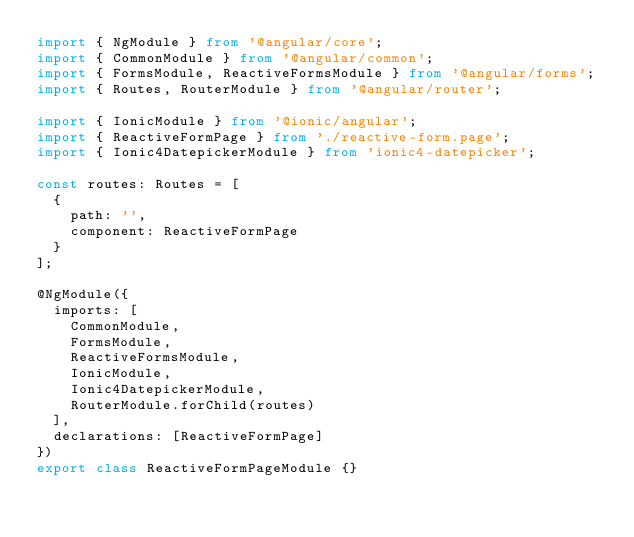<code> <loc_0><loc_0><loc_500><loc_500><_TypeScript_>import { NgModule } from '@angular/core';
import { CommonModule } from '@angular/common';
import { FormsModule, ReactiveFormsModule } from '@angular/forms';
import { Routes, RouterModule } from '@angular/router';

import { IonicModule } from '@ionic/angular';
import { ReactiveFormPage } from './reactive-form.page';
import { Ionic4DatepickerModule } from 'ionic4-datepicker';

const routes: Routes = [
  {
    path: '',
    component: ReactiveFormPage
  }
];

@NgModule({
  imports: [
    CommonModule,
    FormsModule,
    ReactiveFormsModule,
    IonicModule,
    Ionic4DatepickerModule,
    RouterModule.forChild(routes)
  ],
  declarations: [ReactiveFormPage]
})
export class ReactiveFormPageModule {}
</code> 